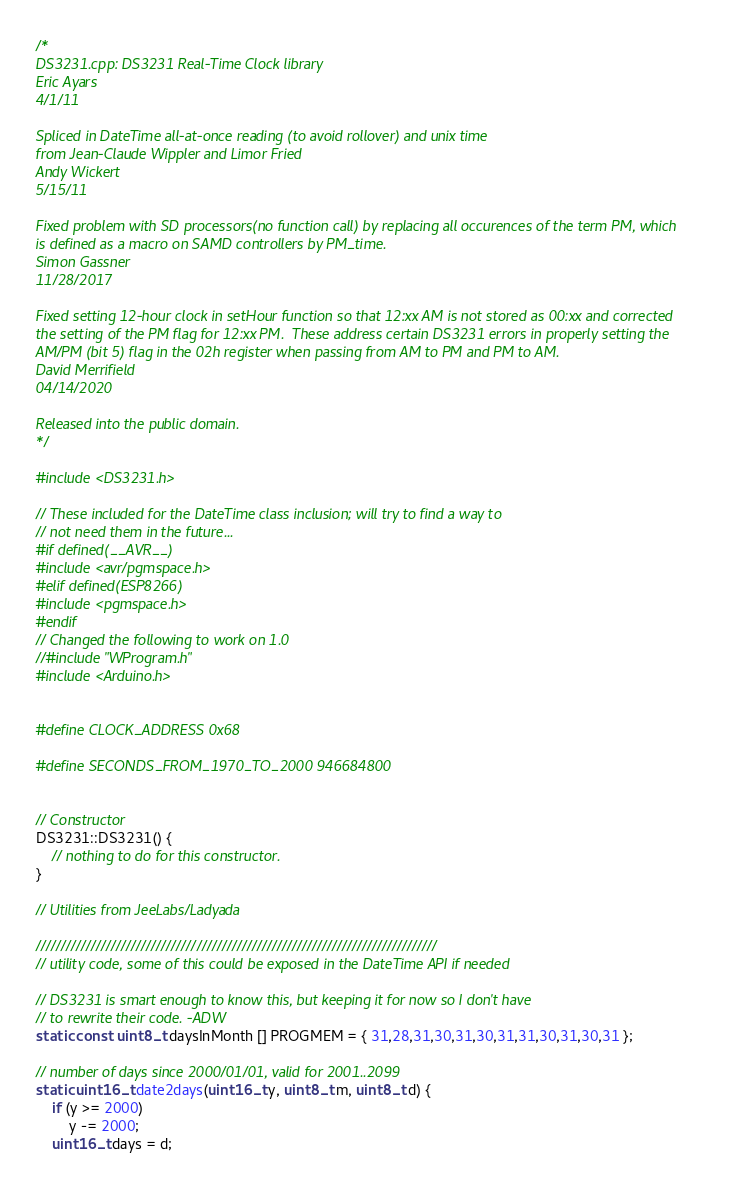Convert code to text. <code><loc_0><loc_0><loc_500><loc_500><_C++_>/*
DS3231.cpp: DS3231 Real-Time Clock library
Eric Ayars
4/1/11

Spliced in DateTime all-at-once reading (to avoid rollover) and unix time
from Jean-Claude Wippler and Limor Fried
Andy Wickert
5/15/11

Fixed problem with SD processors(no function call) by replacing all occurences of the term PM, which
is defined as a macro on SAMD controllers by PM_time. 
Simon Gassner
11/28/2017

Fixed setting 12-hour clock in setHour function so that 12:xx AM is not stored as 00:xx and corrected 
the setting of the PM flag for 12:xx PM.  These address certain DS3231 errors in properly setting the 
AM/PM (bit 5) flag in the 02h register when passing from AM to PM and PM to AM.
David Merrifield
04/14/2020

Released into the public domain.
*/

#include <DS3231.h>

// These included for the DateTime class inclusion; will try to find a way to
// not need them in the future...
#if defined(__AVR__)
#include <avr/pgmspace.h>
#elif defined(ESP8266)
#include <pgmspace.h>
#endif
// Changed the following to work on 1.0
//#include "WProgram.h"
#include <Arduino.h>


#define CLOCK_ADDRESS 0x68

#define SECONDS_FROM_1970_TO_2000 946684800


// Constructor
DS3231::DS3231() {
	// nothing to do for this constructor.
}

// Utilities from JeeLabs/Ladyada

////////////////////////////////////////////////////////////////////////////////
// utility code, some of this could be exposed in the DateTime API if needed

// DS3231 is smart enough to know this, but keeping it for now so I don't have
// to rewrite their code. -ADW
static const uint8_t daysInMonth [] PROGMEM = { 31,28,31,30,31,30,31,31,30,31,30,31 };

// number of days since 2000/01/01, valid for 2001..2099
static uint16_t date2days(uint16_t y, uint8_t m, uint8_t d) {
    if (y >= 2000)
        y -= 2000;
    uint16_t days = d;</code> 